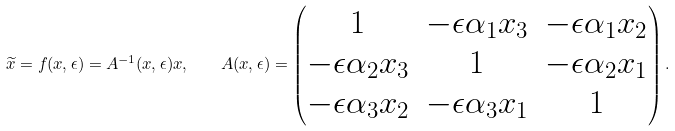Convert formula to latex. <formula><loc_0><loc_0><loc_500><loc_500>\widetilde { x } = f ( x , \epsilon ) = A ^ { - 1 } ( x , \epsilon ) x , \quad A ( x , \epsilon ) = \begin{pmatrix} 1 & - \epsilon \alpha _ { 1 } x _ { 3 } & - \epsilon \alpha _ { 1 } x _ { 2 } \\ - \epsilon \alpha _ { 2 } x _ { 3 } & 1 & - \epsilon \alpha _ { 2 } x _ { 1 } \\ - \epsilon \alpha _ { 3 } x _ { 2 } & - \epsilon \alpha _ { 3 } x _ { 1 } & 1 \end{pmatrix} .</formula> 